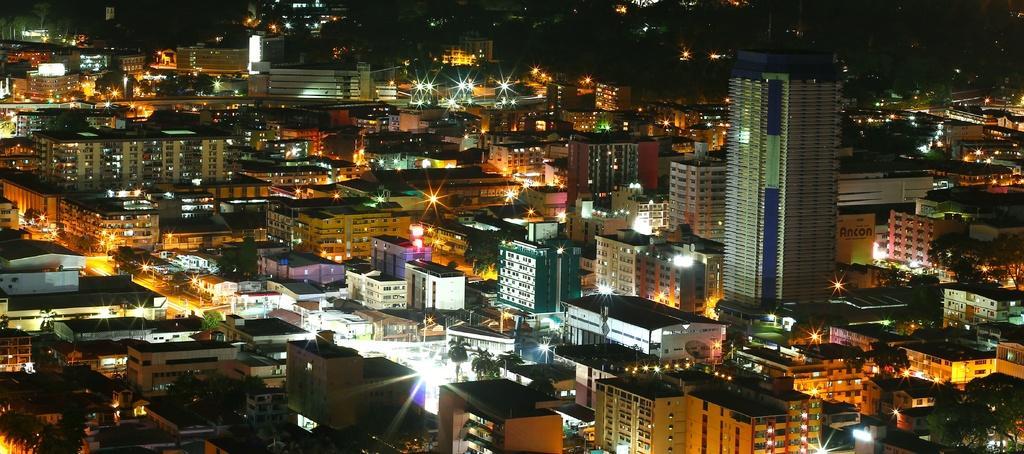Can you describe this image briefly? This is an aerial view. In this picture we can see buildings, trees, lights are present. 